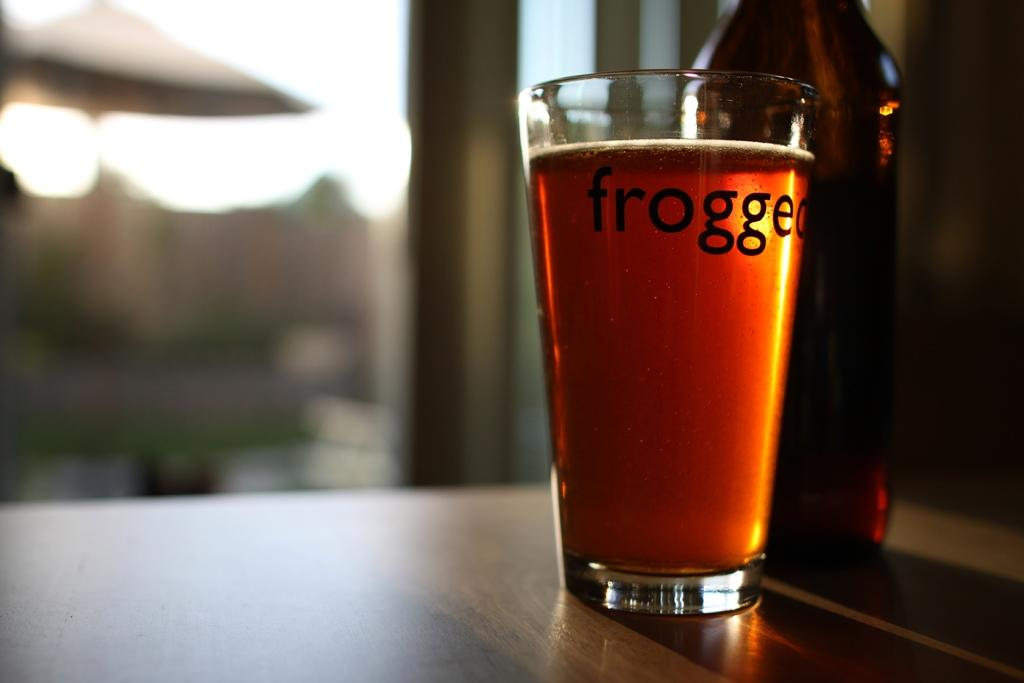<image>
Provide a brief description of the given image. A glass of beer labeled frogged next to its bottle. 